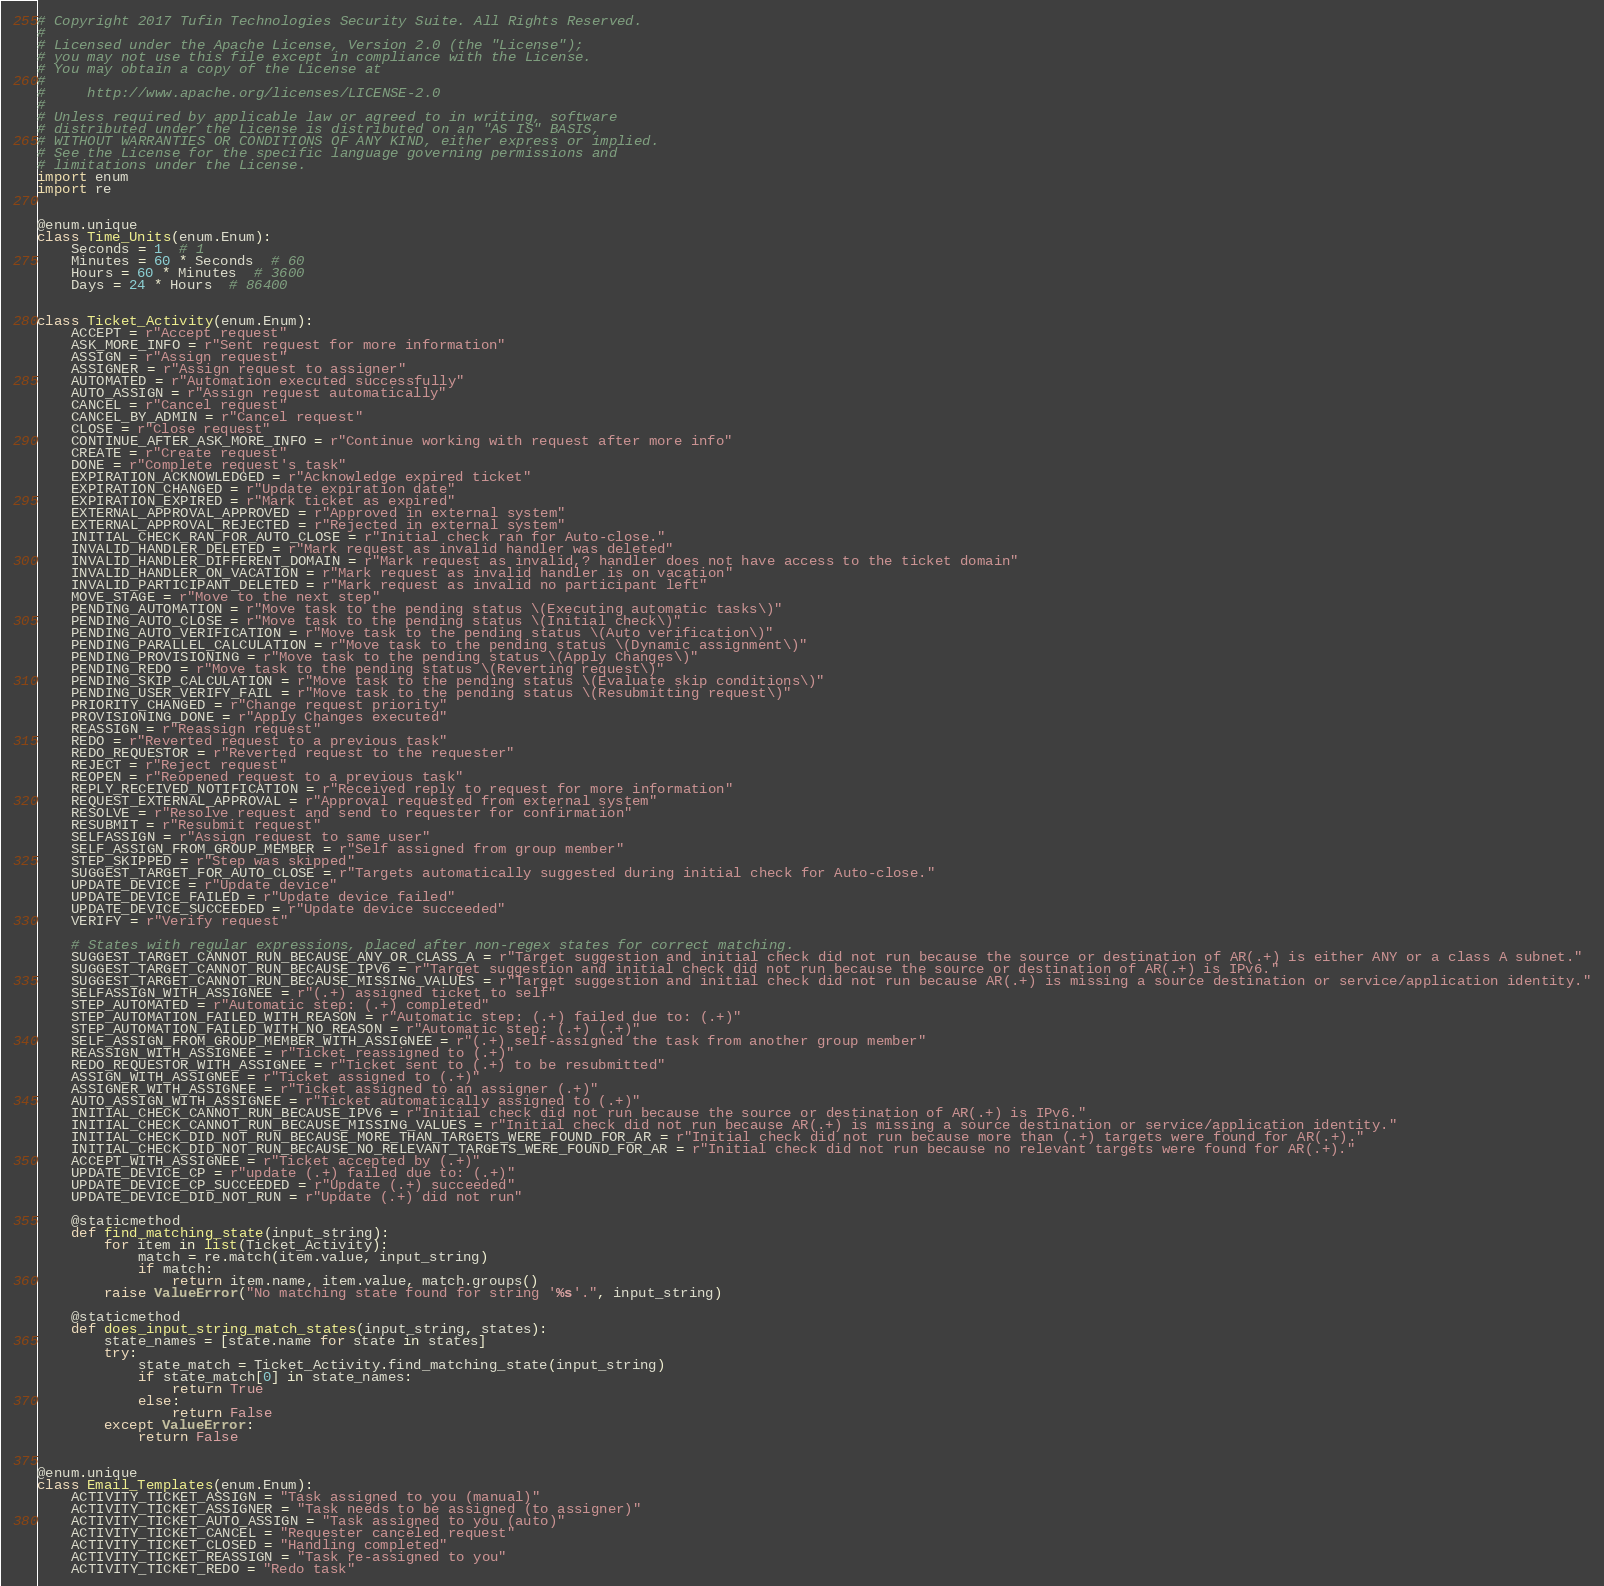Convert code to text. <code><loc_0><loc_0><loc_500><loc_500><_Python_># Copyright 2017 Tufin Technologies Security Suite. All Rights Reserved.
#
# Licensed under the Apache License, Version 2.0 (the "License");
# you may not use this file except in compliance with the License.
# You may obtain a copy of the License at
#
#     http://www.apache.org/licenses/LICENSE-2.0
#
# Unless required by applicable law or agreed to in writing, software
# distributed under the License is distributed on an "AS IS" BASIS,
# WITHOUT WARRANTIES OR CONDITIONS OF ANY KIND, either express or implied.
# See the License for the specific language governing permissions and
# limitations under the License.
import enum
import re


@enum.unique
class Time_Units(enum.Enum):
    Seconds = 1  # 1
    Minutes = 60 * Seconds  # 60
    Hours = 60 * Minutes  # 3600
    Days = 24 * Hours  # 86400


class Ticket_Activity(enum.Enum):
    ACCEPT = r"Accept request"
    ASK_MORE_INFO = r"Sent request for more information"
    ASSIGN = r"Assign request"
    ASSIGNER = r"Assign request to assigner"
    AUTOMATED = r"Automation executed successfully"
    AUTO_ASSIGN = r"Assign request automatically"
    CANCEL = r"Cancel request"
    CANCEL_BY_ADMIN = r"Cancel request"
    CLOSE = r"Close request"
    CONTINUE_AFTER_ASK_MORE_INFO = r"Continue working with request after more info"
    CREATE = r"Create request"
    DONE = r"Complete request's task"
    EXPIRATION_ACKNOWLEDGED = r"Acknowledge expired ticket"
    EXPIRATION_CHANGED = r"Update expiration date"
    EXPIRATION_EXPIRED = r"Mark ticket as expired"
    EXTERNAL_APPROVAL_APPROVED = r"Approved in external system"
    EXTERNAL_APPROVAL_REJECTED = r"Rejected in external system"
    INITIAL_CHECK_RAN_FOR_AUTO_CLOSE = r"Initial check ran for Auto-close."
    INVALID_HANDLER_DELETED = r"Mark request as invalid handler was deleted"
    INVALID_HANDLER_DIFFERENT_DOMAIN = r"Mark request as invalid,? handler does not have access to the ticket domain"
    INVALID_HANDLER_ON_VACATION = r"Mark request as invalid handler is on vacation"
    INVALID_PARTICIPANT_DELETED = r"Mark request as invalid no participant left"
    MOVE_STAGE = r"Move to the next step"
    PENDING_AUTOMATION = r"Move task to the pending status \(Executing automatic tasks\)"
    PENDING_AUTO_CLOSE = r"Move task to the pending status \(Initial check\)"
    PENDING_AUTO_VERIFICATION = r"Move task to the pending status \(Auto verification\)"
    PENDING_PARALLEL_CALCULATION = r"Move task to the pending status \(Dynamic assignment\)"
    PENDING_PROVISIONING = r"Move task to the pending status \(Apply Changes\)"
    PENDING_REDO = r"Move task to the pending status \(Reverting request\)"
    PENDING_SKIP_CALCULATION = r"Move task to the pending status \(Evaluate skip conditions\)"
    PENDING_USER_VERIFY_FAIL = r"Move task to the pending status \(Resubmitting request\)"
    PRIORITY_CHANGED = r"Change request priority"
    PROVISIONING_DONE = r"Apply Changes executed"
    REASSIGN = r"Reassign request"
    REDO = r"Reverted request to a previous task"
    REDO_REQUESTOR = r"Reverted request to the requester"
    REJECT = r"Reject request"
    REOPEN = r"Reopened request to a previous task"
    REPLY_RECEIVED_NOTIFICATION = r"Received reply to request for more information"
    REQUEST_EXTERNAL_APPROVAL = r"Approval requested from external system"
    RESOLVE = r"Resolve request and send to requester for confirmation"
    RESUBMIT = r"Resubmit request"
    SELFASSIGN = r"Assign request to same user"
    SELF_ASSIGN_FROM_GROUP_MEMBER = r"Self assigned from group member"
    STEP_SKIPPED = r"Step was skipped"
    SUGGEST_TARGET_FOR_AUTO_CLOSE = r"Targets automatically suggested during initial check for Auto-close."
    UPDATE_DEVICE = r"Update device"
    UPDATE_DEVICE_FAILED = r"Update device failed"
    UPDATE_DEVICE_SUCCEEDED = r"Update device succeeded"
    VERIFY = r"Verify request"

    # States with regular expressions, placed after non-regex states for correct matching.
    SUGGEST_TARGET_CANNOT_RUN_BECAUSE_ANY_OR_CLASS_A = r"Target suggestion and initial check did not run because the source or destination of AR(.+) is either ANY or a class A subnet."
    SUGGEST_TARGET_CANNOT_RUN_BECAUSE_IPV6 = r"Target suggestion and initial check did not run because the source or destination of AR(.+) is IPv6."
    SUGGEST_TARGET_CANNOT_RUN_BECAUSE_MISSING_VALUES = r"Target suggestion and initial check did not run because AR(.+) is missing a source destination or service/application identity."
    SELFASSIGN_WITH_ASSIGNEE = r"(.+) assigned ticket to self"
    STEP_AUTOMATED = r"Automatic step: (.+) completed"
    STEP_AUTOMATION_FAILED_WITH_REASON = r"Automatic step: (.+) failed due to: (.+)"
    STEP_AUTOMATION_FAILED_WITH_NO_REASON = r"Automatic step: (.+) (.+)"
    SELF_ASSIGN_FROM_GROUP_MEMBER_WITH_ASSIGNEE = r"(.+) self-assigned the task from another group member"
    REASSIGN_WITH_ASSIGNEE = r"Ticket reassigned to (.+)"
    REDO_REQUESTOR_WITH_ASSIGNEE = r"Ticket sent to (.+) to be resubmitted"
    ASSIGN_WITH_ASSIGNEE = r"Ticket assigned to (.+)"
    ASSIGNER_WITH_ASSIGNEE = r"Ticket assigned to an assigner (.+)"
    AUTO_ASSIGN_WITH_ASSIGNEE = r"Ticket automatically assigned to (.+)"
    INITIAL_CHECK_CANNOT_RUN_BECAUSE_IPV6 = r"Initial check did not run because the source or destination of AR(.+) is IPv6."
    INITIAL_CHECK_CANNOT_RUN_BECAUSE_MISSING_VALUES = r"Initial check did not run because AR(.+) is missing a source destination or service/application identity."
    INITIAL_CHECK_DID_NOT_RUN_BECAUSE_MORE_THAN_TARGETS_WERE_FOUND_FOR_AR = r"Initial check did not run because more than (.+) targets were found for AR(.+)."
    INITIAL_CHECK_DID_NOT_RUN_BECAUSE_NO_RELEVANT_TARGETS_WERE_FOUND_FOR_AR = r"Initial check did not run because no relevant targets were found for AR(.+)."
    ACCEPT_WITH_ASSIGNEE = r"Ticket accepted by (.+)"
    UPDATE_DEVICE_CP = r"update (.+) failed due to: (.+)"
    UPDATE_DEVICE_CP_SUCCEEDED = r"Update (.+) succeeded"
    UPDATE_DEVICE_DID_NOT_RUN = r"Update (.+) did not run"

    @staticmethod
    def find_matching_state(input_string):
        for item in list(Ticket_Activity):
            match = re.match(item.value, input_string)
            if match:
                return item.name, item.value, match.groups()
        raise ValueError("No matching state found for string '%s'.", input_string)

    @staticmethod
    def does_input_string_match_states(input_string, states):
        state_names = [state.name for state in states]
        try:
            state_match = Ticket_Activity.find_matching_state(input_string)
            if state_match[0] in state_names:
                return True
            else:
                return False
        except ValueError:
            return False


@enum.unique
class Email_Templates(enum.Enum):
    ACTIVITY_TICKET_ASSIGN = "Task assigned to you (manual)"
    ACTIVITY_TICKET_ASSIGNER = "Task needs to be assigned (to assigner)"
    ACTIVITY_TICKET_AUTO_ASSIGN = "Task assigned to you (auto)"
    ACTIVITY_TICKET_CANCEL = "Requester canceled request"
    ACTIVITY_TICKET_CLOSED = "Handling completed"
    ACTIVITY_TICKET_REASSIGN = "Task re-assigned to you"
    ACTIVITY_TICKET_REDO = "Redo task"</code> 